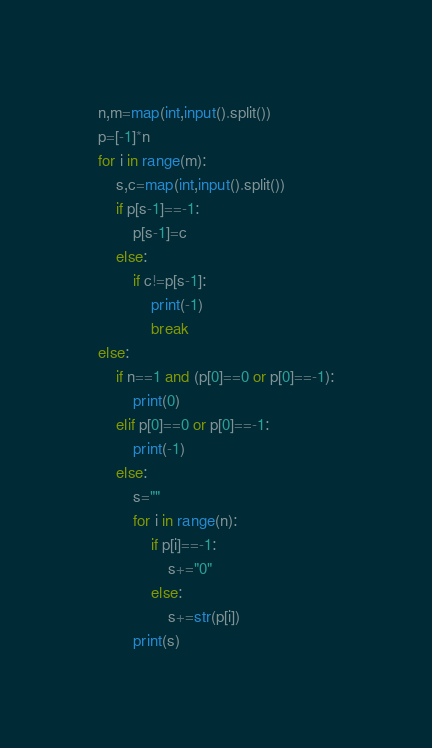Convert code to text. <code><loc_0><loc_0><loc_500><loc_500><_Python_>n,m=map(int,input().split())
p=[-1]*n
for i in range(m):
    s,c=map(int,input().split())
    if p[s-1]==-1:
        p[s-1]=c
    else:
        if c!=p[s-1]:
            print(-1)
            break
else:
    if n==1 and (p[0]==0 or p[0]==-1):
        print(0)
    elif p[0]==0 or p[0]==-1:
        print(-1)
    else:
        s=""
        for i in range(n):
            if p[i]==-1:
                s+="0"
            else:
                s+=str(p[i])
        print(s)</code> 